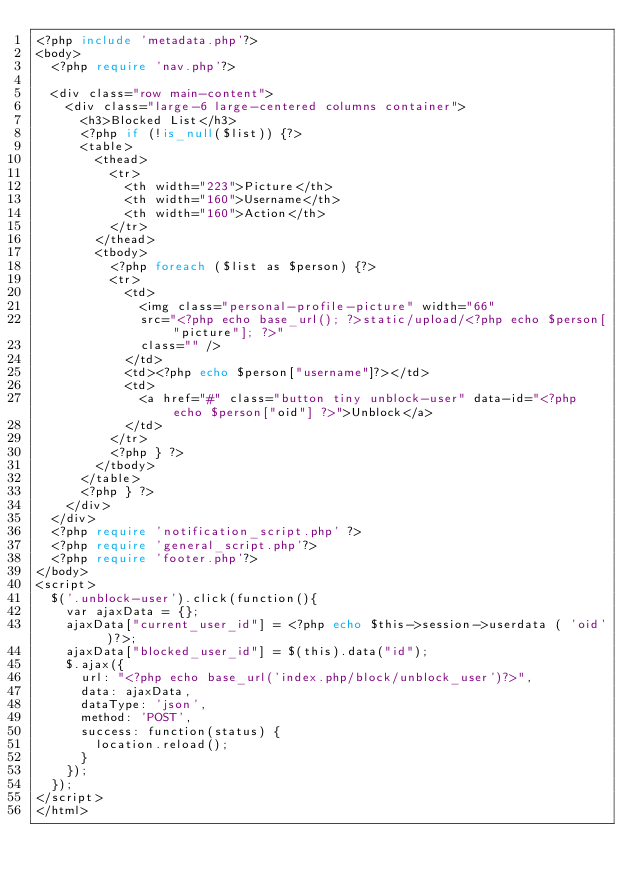<code> <loc_0><loc_0><loc_500><loc_500><_PHP_><?php include 'metadata.php'?>
<body>
	<?php require 'nav.php'?>
	
	<div class="row main-content">
		<div class="large-6 large-centered columns container">
			<h3>Blocked List</h3>
			<?php if (!is_null($list)) {?>
			<table>
				<thead>
					<tr>
						<th width="223">Picture</th>
						<th width="160">Username</th>
						<th width="160">Action</th>
					</tr>
				</thead>
				<tbody>
					<?php foreach ($list as $person) {?>
					<tr>
						<td>
							<img class="personal-profile-picture" width="66"
							src="<?php echo base_url(); ?>static/upload/<?php echo $person["picture"]; ?>"
							class="" />
						</td>
						<td><?php echo $person["username"]?></td>
						<td>
							<a href="#" class="button tiny unblock-user" data-id="<?php echo $person["oid"] ?>">Unblock</a>
						</td>
					</tr>
					<?php } ?>
				</tbody>
			</table>
			<?php } ?>
		</div>
	</div>
	<?php require 'notification_script.php' ?>
	<?php require 'general_script.php'?>
	<?php require 'footer.php'?>
</body>
<script>
	$('.unblock-user').click(function(){
		var ajaxData = {};
		ajaxData["current_user_id"] = <?php echo $this->session->userdata ( 'oid' )?>;
		ajaxData["blocked_user_id"] = $(this).data("id");
		$.ajax({
			url: "<?php echo base_url('index.php/block/unblock_user')?>",
			data: ajaxData,
			dataType: 'json',
			method: 'POST',
			success: function(status) {
				location.reload();
			}
		});
	});
</script>
</html></code> 